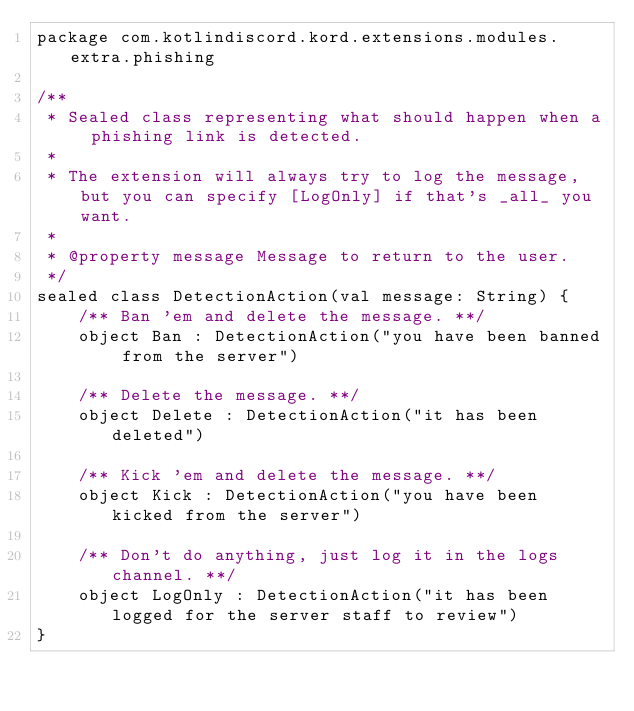Convert code to text. <code><loc_0><loc_0><loc_500><loc_500><_Kotlin_>package com.kotlindiscord.kord.extensions.modules.extra.phishing

/**
 * Sealed class representing what should happen when a phishing link is detected.
 *
 * The extension will always try to log the message, but you can specify [LogOnly] if that's _all_ you want.
 *
 * @property message Message to return to the user.
 */
sealed class DetectionAction(val message: String) {
    /** Ban 'em and delete the message. **/
    object Ban : DetectionAction("you have been banned from the server")

    /** Delete the message. **/
    object Delete : DetectionAction("it has been deleted")

    /** Kick 'em and delete the message. **/
    object Kick : DetectionAction("you have been kicked from the server")

    /** Don't do anything, just log it in the logs channel. **/
    object LogOnly : DetectionAction("it has been logged for the server staff to review")
}
</code> 